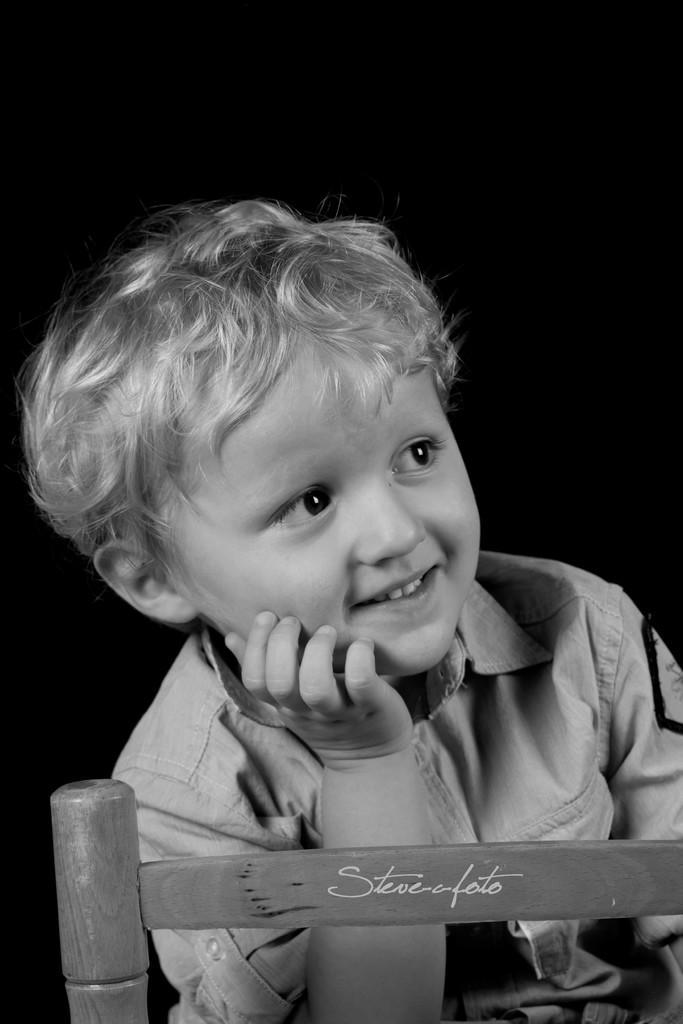Can you describe this image briefly? This is a black and white image. In this image we can see a kid smiling. At the bottom of the image there is a wooden object with some text. The background of the image is dark. 